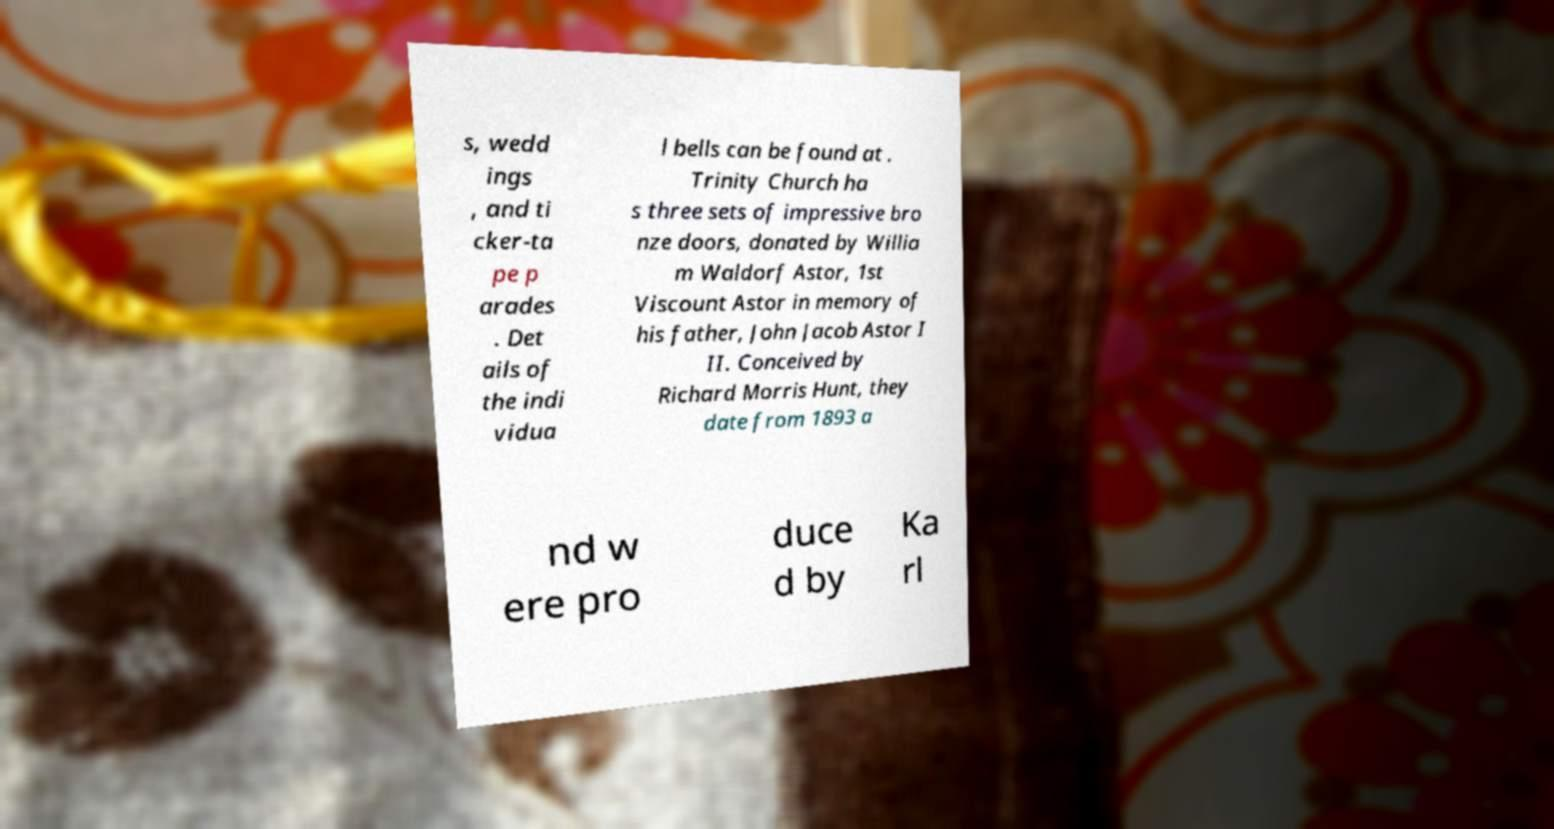Could you extract and type out the text from this image? s, wedd ings , and ti cker-ta pe p arades . Det ails of the indi vidua l bells can be found at . Trinity Church ha s three sets of impressive bro nze doors, donated by Willia m Waldorf Astor, 1st Viscount Astor in memory of his father, John Jacob Astor I II. Conceived by Richard Morris Hunt, they date from 1893 a nd w ere pro duce d by Ka rl 